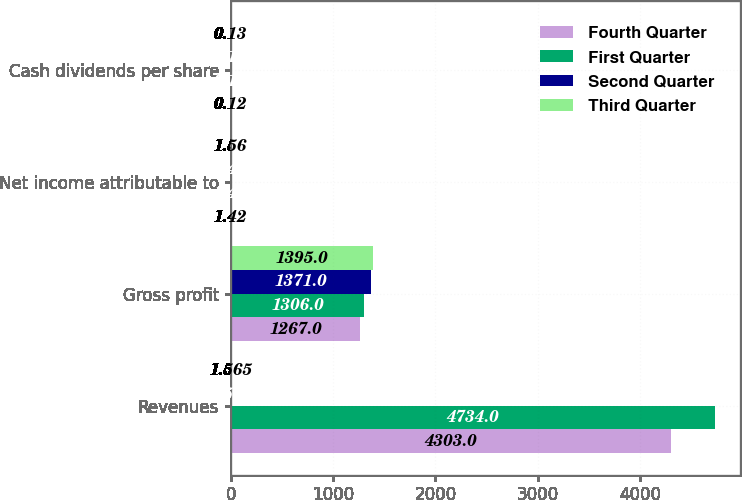<chart> <loc_0><loc_0><loc_500><loc_500><stacked_bar_chart><ecel><fcel>Revenues<fcel>Gross profit<fcel>Net income attributable to<fcel>Cash dividends per share<nl><fcel>Fourth Quarter<fcel>4303<fcel>1267<fcel>1.42<fcel>0.12<nl><fcel>First Quarter<fcel>4734<fcel>1306<fcel>1.42<fcel>0.12<nl><fcel>Second Quarter<fcel>1.565<fcel>1371<fcel>1.43<fcel>0.12<nl><fcel>Third Quarter<fcel>1.565<fcel>1395<fcel>1.56<fcel>0.13<nl></chart> 